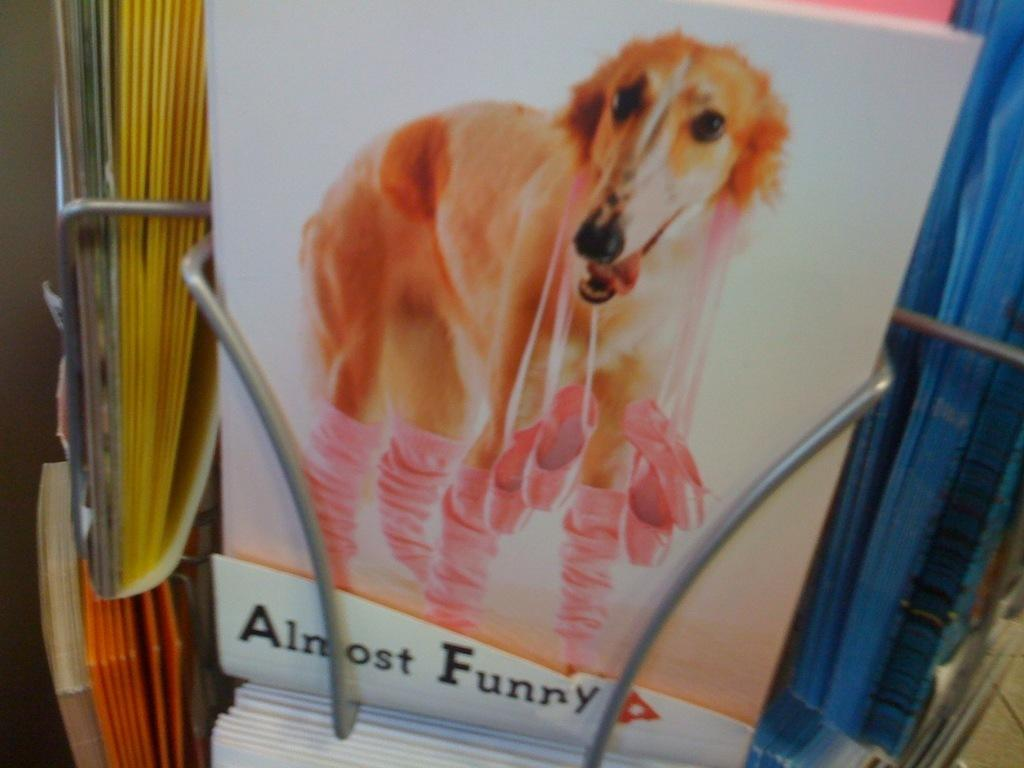What type of furniture is present in the image? There is a bookshelf in the image. What is placed on the bookshelf? There is a book on the bookshelf. What is depicted on the book's cover? The book has a picture of a dog. Is there any text on the book? Yes, there is text at the bottom of the book. How many buckets are used to sort the dust in the image? There is no mention of dust or buckets in the image; it features a bookshelf with a book on it. 